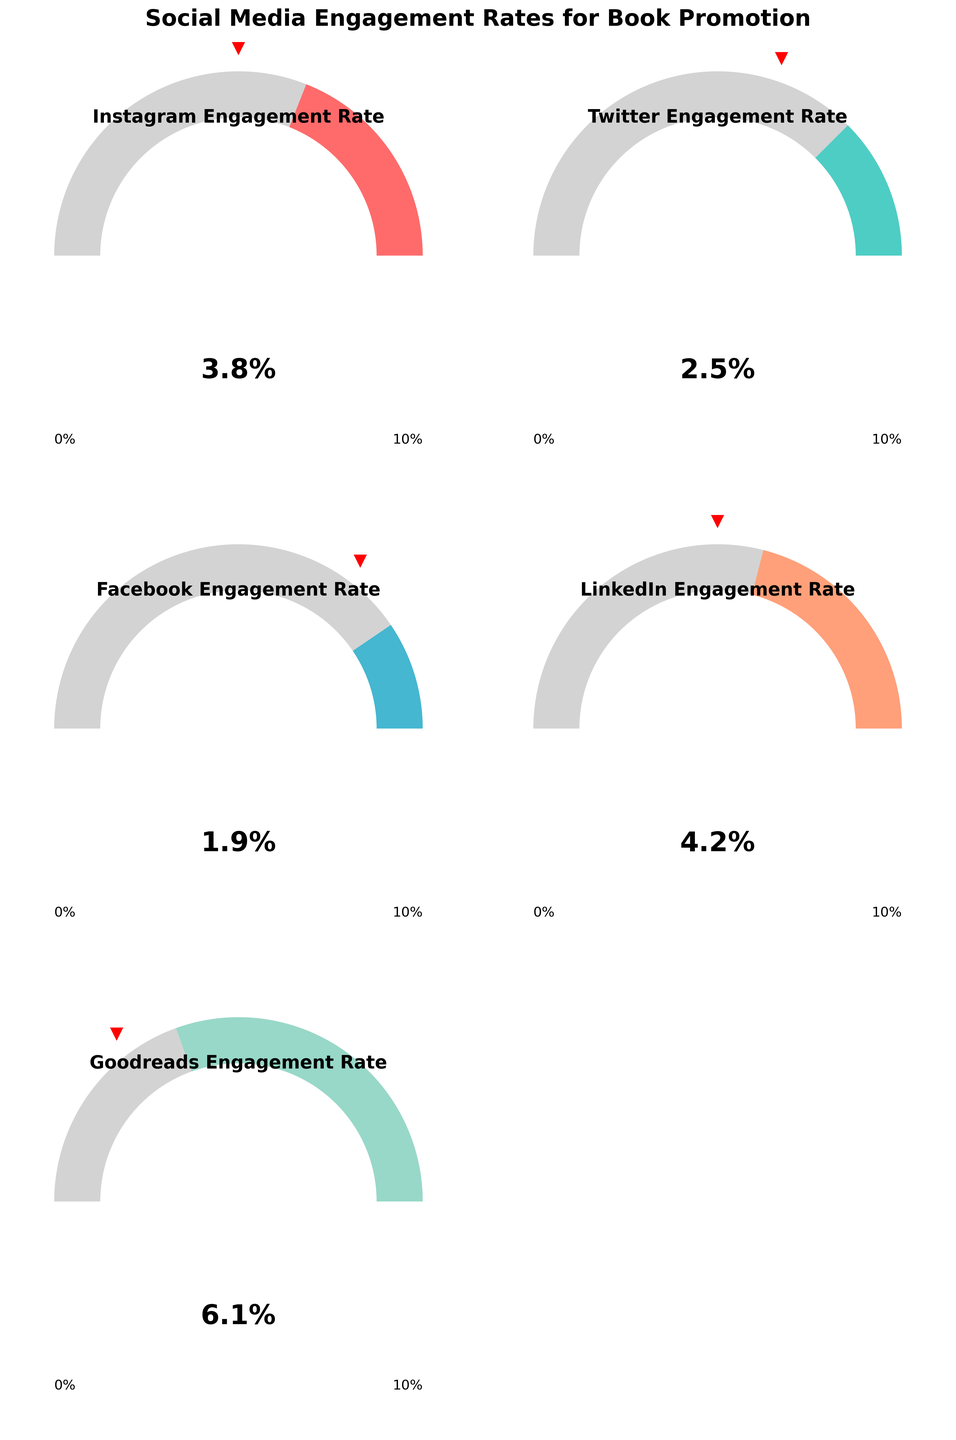What is the engagement rate for LinkedIn? The gauge chart labeled "LinkedIn Engagement Rate" shows the value for LinkedIn. The needle on the gauge points to the engagement rate value, which is written as text below the needle.
Answer: 4.2% Is Goodreads' engagement rate higher or lower than its target? The gauge chart for "Goodreads Engagement Rate" has a value of 6.1%. The small red marker shows the target, which is labeled 7%. Since 6.1% is less than 7%, the engagement rate is lower than the target.
Answer: Lower Which social media platform has the highest engagement rate? By comparing the needle positions on all gauge charts, "Goodreads Engagement Rate" shows the highest value of 6.1%, as indicated by its needle position and the numerical value displayed.
Answer: Goodreads How far is the Twitter engagement rate from reaching its target? The gauge chart for "Twitter Engagement Rate" shows a current value of 2.5%. The red marker shows the target is 4%. Calculate the difference between the target and the actual value: \(4 - 2.5 = 1.5\).
Answer: 1.5% Which platform has the closest engagement rate to its target? Compare the difference between the actual engagement rates and their respective targets for all platforms: Instagram (3.8% vs 5%), Twitter (2.5% vs 4%), Facebook (1.9% vs 3%), LinkedIn (4.2% vs 5%), Goodreads (6.1% vs 7%). The smallest difference is for Instagram: \(5 - 3.8 = 1.2\).
Answer: Instagram What is the average engagement rate across all platforms? Add up all the engagement rates: \(3.8 + 2.5 + 1.9 + 4.2 + 6.1 = 18.5\). Divide by the number of platforms, which is 5: \(18.5 / 5 = 3.7\).
Answer: 3.7% Between Instagram and Facebook, which platform needs more improvement to reach its target? Calculate the difference for each: Instagram needs \(5 - 3.8 = 1.2\) and Facebook needs \(3 - 1.9 = 1.1\). Since the Instagram difference (1.2) is greater than Facebook's (1.1), Instagram needs more improvement.
Answer: Instagram By how much does the Instagram engagement rate exceed the Facebook engagement rate? Subtract Facebook's engagement rate from Instagram's engagement rate: \(3.8 - 1.9 = 1.9\).
Answer: 1.9% What is the combined value of engagement rates for all platforms aiming for a target of 5% or more? Identify platforms with a target of 5% or more: Instagram (5%), LinkedIn (5%), Goodreads (7%). Add their engagement rates: \(3.8 + 4.2 + 6.1 = 14.1\).
Answer: 14.1 What is the difference between the highest and lowest engagement rates among all platforms? Identify the highest (Goodreads at 6.1%) and lowest (Facebook at 1.9%) engagement rates. Subtract the lowest from the highest: \(6.1 - 1.9 = 4.2\).
Answer: 4.2 